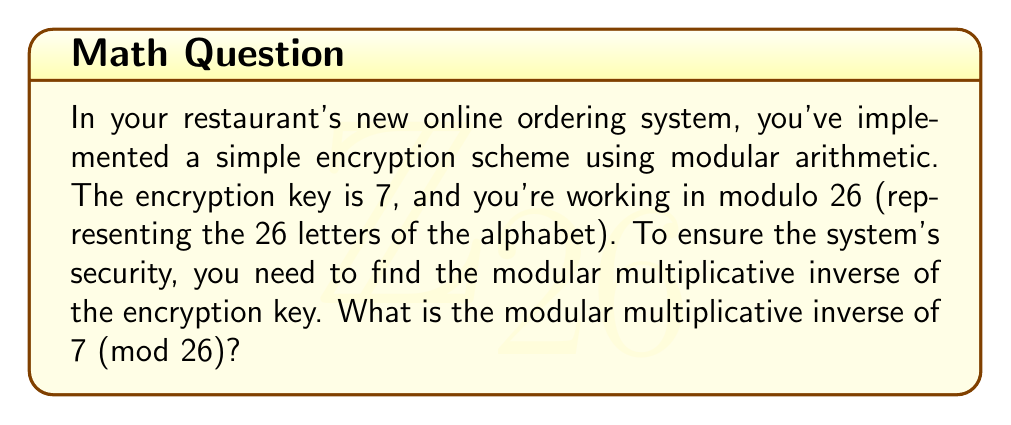What is the answer to this math problem? To find the modular multiplicative inverse of 7 (mod 26), we need to find a number $x$ such that:

$$(7x) \equiv 1 \pmod{26}$$

We can use the extended Euclidean algorithm to solve this:

1) First, let's set up the initial values:
   $26 = 3 \times 7 + 5$
   $7 = 1 \times 5 + 2$
   $5 = 2 \times 2 + 1$
   $2 = 2 \times 1 + 0$

2) Now, we work backwards:
   $1 = 5 - 2 \times 2$
   $1 = 5 - 2 \times (7 - 1 \times 5) = 3 \times 5 - 2 \times 7$
   $1 = 3 \times (26 - 3 \times 7) - 2 \times 7 = 3 \times 26 - 11 \times 7$

3) Therefore, $(-11 \times 7) \equiv 1 \pmod{26}$

4) We need a positive number less than 26, so we add 26 to -11 until we get a positive number less than 26:
   $-11 + 26 = 15$

5) Verify: $(15 \times 7) \bmod 26 = 105 \bmod 26 = 1$

Thus, the modular multiplicative inverse of 7 (mod 26) is 15.
Answer: 15 